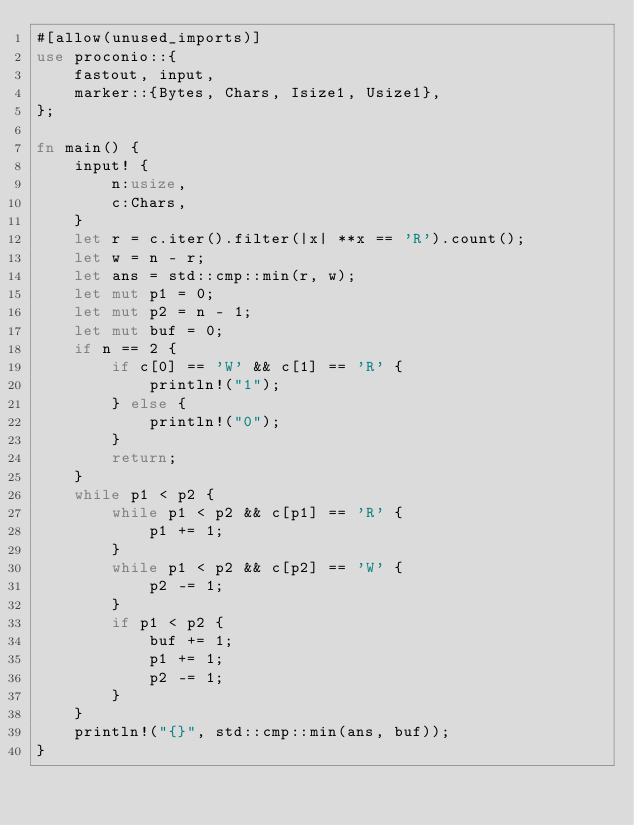Convert code to text. <code><loc_0><loc_0><loc_500><loc_500><_Rust_>#[allow(unused_imports)]
use proconio::{
    fastout, input,
    marker::{Bytes, Chars, Isize1, Usize1},
};

fn main() {
    input! {
        n:usize,
        c:Chars,
    }
    let r = c.iter().filter(|x| **x == 'R').count();
    let w = n - r;
    let ans = std::cmp::min(r, w);
    let mut p1 = 0;
    let mut p2 = n - 1;
    let mut buf = 0;
    if n == 2 {
        if c[0] == 'W' && c[1] == 'R' {
            println!("1");
        } else {
            println!("0");
        }
        return;
    }
    while p1 < p2 {
        while p1 < p2 && c[p1] == 'R' {
            p1 += 1;
        }
        while p1 < p2 && c[p2] == 'W' {
            p2 -= 1;
        }
        if p1 < p2 {
            buf += 1;
            p1 += 1;
            p2 -= 1;
        }
    }
    println!("{}", std::cmp::min(ans, buf));
}
</code> 